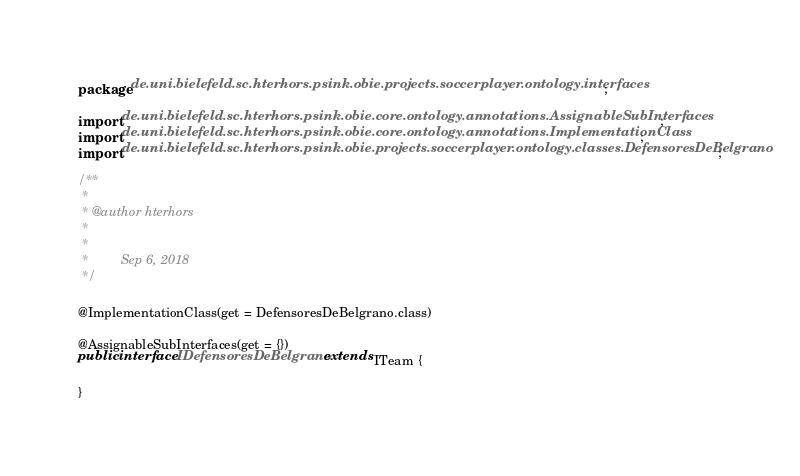<code> <loc_0><loc_0><loc_500><loc_500><_Java_>package de.uni.bielefeld.sc.hterhors.psink.obie.projects.soccerplayer.ontology.interfaces;

import de.uni.bielefeld.sc.hterhors.psink.obie.core.ontology.annotations.AssignableSubInterfaces;
import de.uni.bielefeld.sc.hterhors.psink.obie.core.ontology.annotations.ImplementationClass;
import de.uni.bielefeld.sc.hterhors.psink.obie.projects.soccerplayer.ontology.classes.DefensoresDeBelgrano;

/**
 *
 * @author hterhors
 *
 *
 *         Sep 6, 2018
 */

@ImplementationClass(get = DefensoresDeBelgrano.class)

@AssignableSubInterfaces(get = {})
public interface IDefensoresDeBelgrano extends ITeam {

}
</code> 